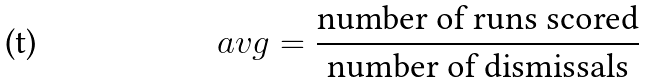<formula> <loc_0><loc_0><loc_500><loc_500>a v g & = \frac { \text {number of runs scored} } { \text {number of dismissals} }</formula> 